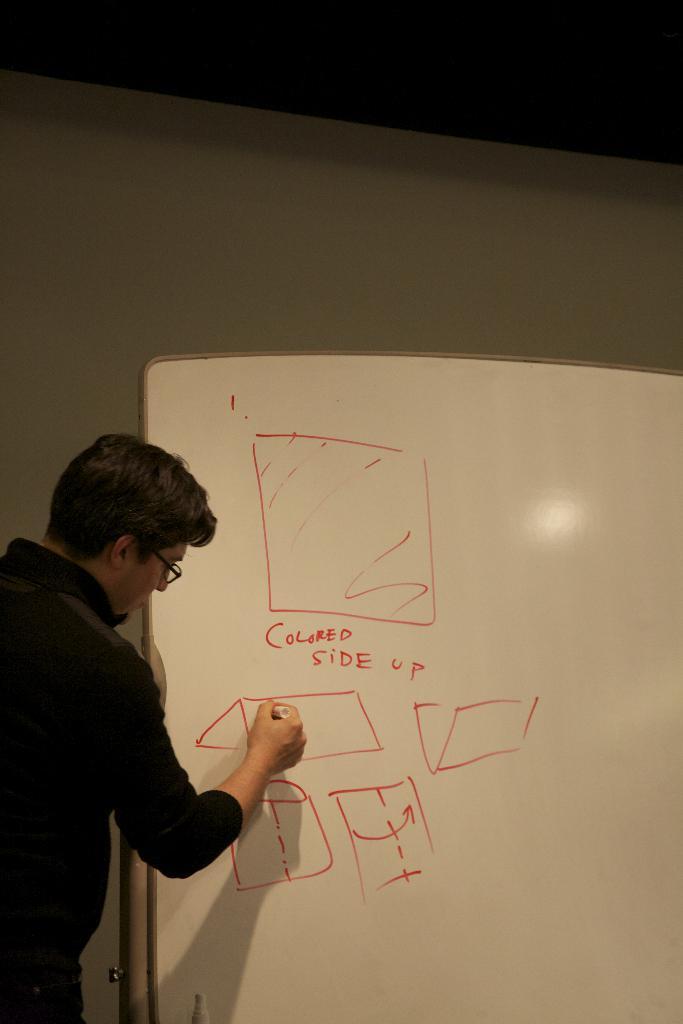Please provide a concise description of this image. In the picture there is man he is writing something on the board with a red sketch and behind the board there is a wall. 